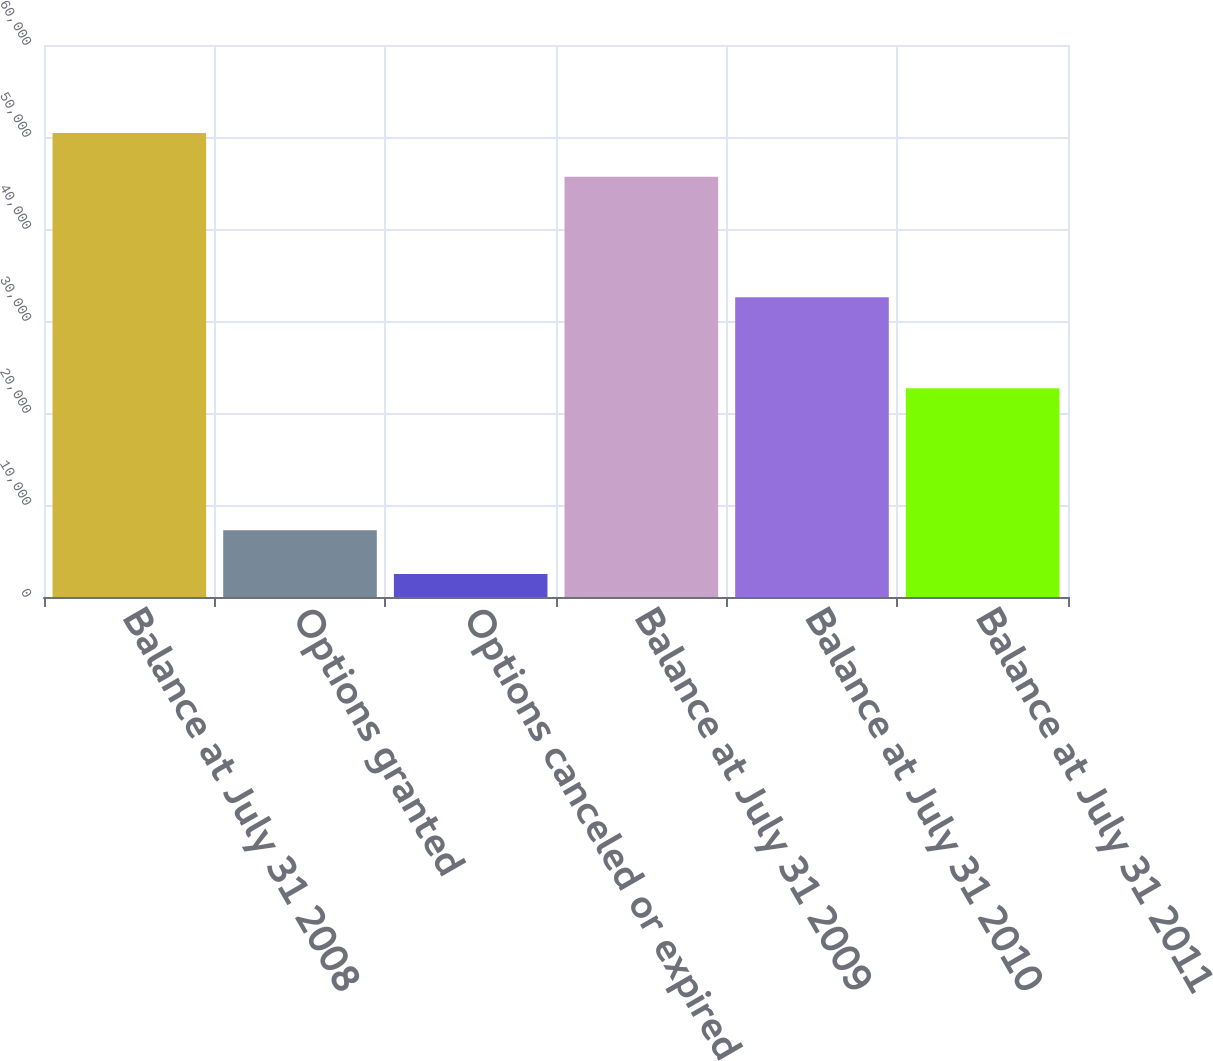Convert chart to OTSL. <chart><loc_0><loc_0><loc_500><loc_500><bar_chart><fcel>Balance at July 31 2008<fcel>Options granted<fcel>Options canceled or expired<fcel>Balance at July 31 2009<fcel>Balance at July 31 2010<fcel>Balance at July 31 2011<nl><fcel>50445.8<fcel>7259.8<fcel>2488<fcel>45674<fcel>32593<fcel>22679<nl></chart> 